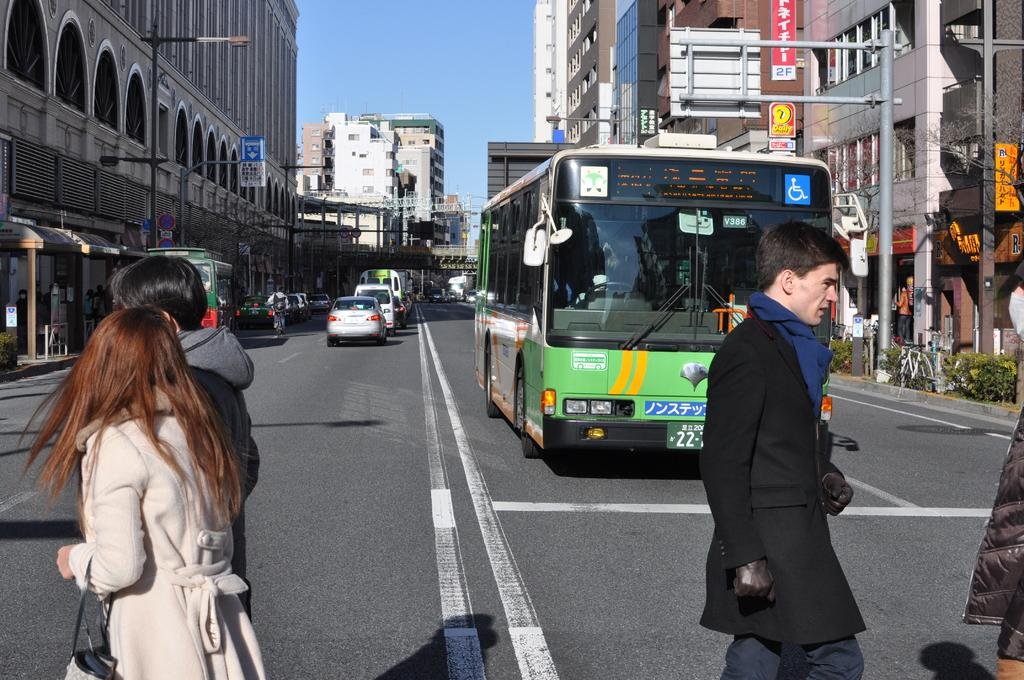Provide a one-sentence caption for the provided image. A city street with a green bus with V386 on windshield. 